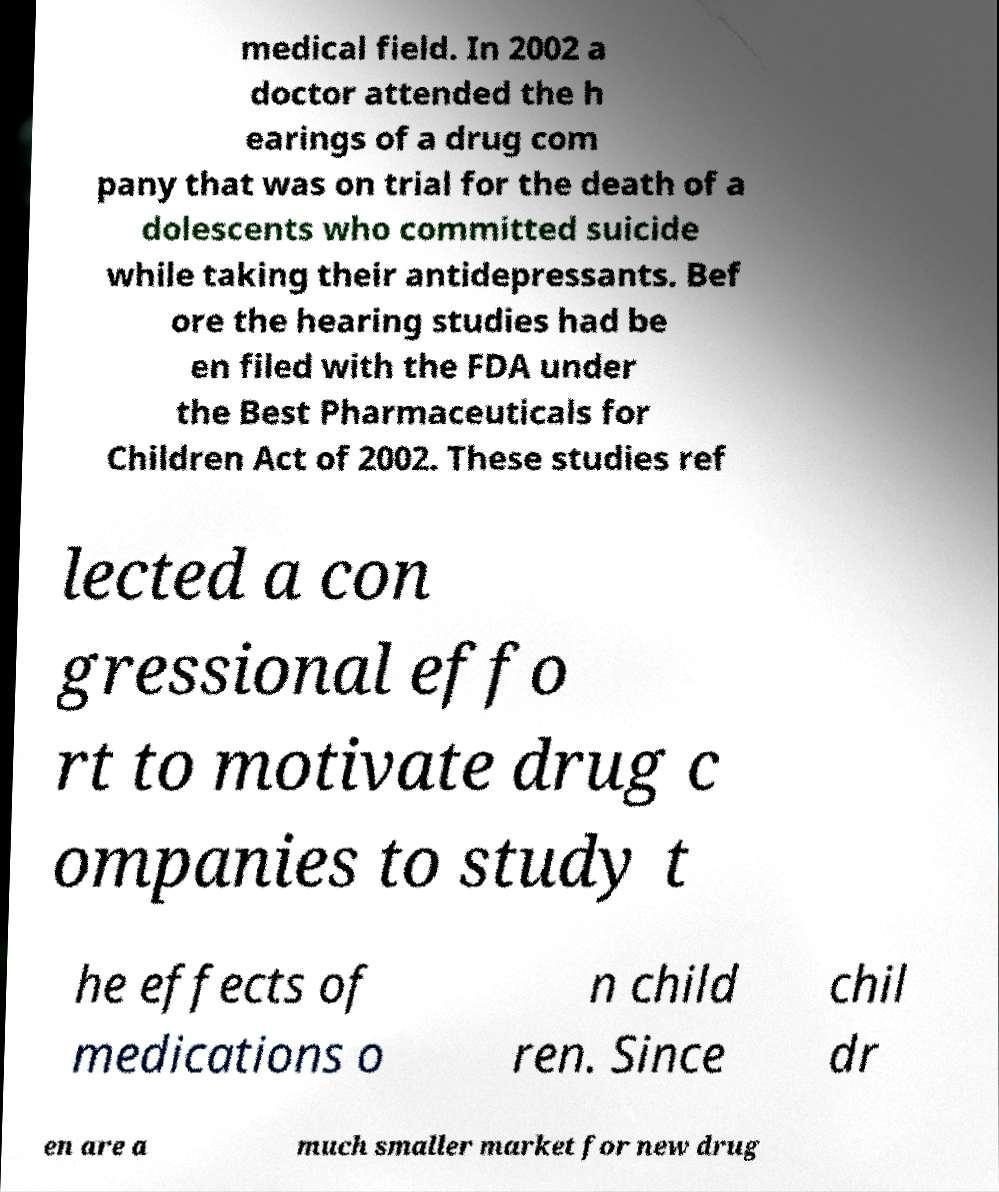What messages or text are displayed in this image? I need them in a readable, typed format. medical field. In 2002 a doctor attended the h earings of a drug com pany that was on trial for the death of a dolescents who committed suicide while taking their antidepressants. Bef ore the hearing studies had be en filed with the FDA under the Best Pharmaceuticals for Children Act of 2002. These studies ref lected a con gressional effo rt to motivate drug c ompanies to study t he effects of medications o n child ren. Since chil dr en are a much smaller market for new drug 